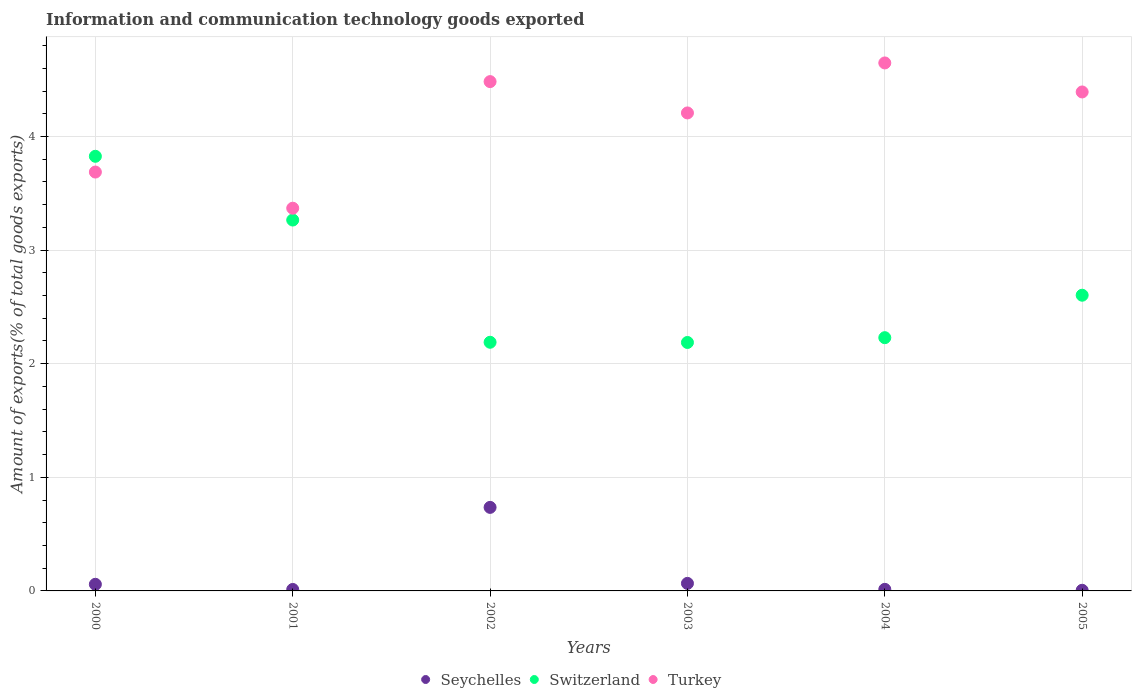How many different coloured dotlines are there?
Make the answer very short. 3. Is the number of dotlines equal to the number of legend labels?
Provide a short and direct response. Yes. What is the amount of goods exported in Switzerland in 2004?
Give a very brief answer. 2.23. Across all years, what is the maximum amount of goods exported in Seychelles?
Provide a succinct answer. 0.74. Across all years, what is the minimum amount of goods exported in Seychelles?
Provide a succinct answer. 0.01. What is the total amount of goods exported in Switzerland in the graph?
Provide a short and direct response. 16.3. What is the difference between the amount of goods exported in Switzerland in 2002 and that in 2005?
Provide a short and direct response. -0.41. What is the difference between the amount of goods exported in Seychelles in 2003 and the amount of goods exported in Turkey in 2000?
Keep it short and to the point. -3.62. What is the average amount of goods exported in Switzerland per year?
Offer a very short reply. 2.72. In the year 2001, what is the difference between the amount of goods exported in Switzerland and amount of goods exported in Turkey?
Ensure brevity in your answer.  -0.1. In how many years, is the amount of goods exported in Switzerland greater than 4.2 %?
Your answer should be very brief. 0. What is the ratio of the amount of goods exported in Switzerland in 2001 to that in 2005?
Provide a succinct answer. 1.25. What is the difference between the highest and the second highest amount of goods exported in Seychelles?
Provide a succinct answer. 0.67. What is the difference between the highest and the lowest amount of goods exported in Seychelles?
Ensure brevity in your answer.  0.73. Is the sum of the amount of goods exported in Switzerland in 2000 and 2004 greater than the maximum amount of goods exported in Seychelles across all years?
Provide a short and direct response. Yes. Is it the case that in every year, the sum of the amount of goods exported in Turkey and amount of goods exported in Switzerland  is greater than the amount of goods exported in Seychelles?
Offer a very short reply. Yes. Is the amount of goods exported in Seychelles strictly less than the amount of goods exported in Switzerland over the years?
Give a very brief answer. Yes. How many dotlines are there?
Your answer should be compact. 3. How many years are there in the graph?
Offer a terse response. 6. Does the graph contain grids?
Provide a short and direct response. Yes. How many legend labels are there?
Your response must be concise. 3. How are the legend labels stacked?
Provide a short and direct response. Horizontal. What is the title of the graph?
Give a very brief answer. Information and communication technology goods exported. Does "Guatemala" appear as one of the legend labels in the graph?
Your answer should be compact. No. What is the label or title of the X-axis?
Provide a short and direct response. Years. What is the label or title of the Y-axis?
Offer a terse response. Amount of exports(% of total goods exports). What is the Amount of exports(% of total goods exports) in Seychelles in 2000?
Provide a short and direct response. 0.06. What is the Amount of exports(% of total goods exports) of Switzerland in 2000?
Give a very brief answer. 3.83. What is the Amount of exports(% of total goods exports) in Turkey in 2000?
Give a very brief answer. 3.69. What is the Amount of exports(% of total goods exports) in Seychelles in 2001?
Offer a very short reply. 0.01. What is the Amount of exports(% of total goods exports) of Switzerland in 2001?
Your answer should be very brief. 3.26. What is the Amount of exports(% of total goods exports) in Turkey in 2001?
Offer a very short reply. 3.37. What is the Amount of exports(% of total goods exports) of Seychelles in 2002?
Your answer should be very brief. 0.74. What is the Amount of exports(% of total goods exports) of Switzerland in 2002?
Give a very brief answer. 2.19. What is the Amount of exports(% of total goods exports) in Turkey in 2002?
Make the answer very short. 4.48. What is the Amount of exports(% of total goods exports) of Seychelles in 2003?
Offer a terse response. 0.07. What is the Amount of exports(% of total goods exports) in Switzerland in 2003?
Ensure brevity in your answer.  2.19. What is the Amount of exports(% of total goods exports) of Turkey in 2003?
Give a very brief answer. 4.21. What is the Amount of exports(% of total goods exports) in Seychelles in 2004?
Offer a very short reply. 0.01. What is the Amount of exports(% of total goods exports) in Switzerland in 2004?
Your response must be concise. 2.23. What is the Amount of exports(% of total goods exports) of Turkey in 2004?
Your response must be concise. 4.65. What is the Amount of exports(% of total goods exports) in Seychelles in 2005?
Make the answer very short. 0.01. What is the Amount of exports(% of total goods exports) in Switzerland in 2005?
Provide a short and direct response. 2.6. What is the Amount of exports(% of total goods exports) in Turkey in 2005?
Provide a short and direct response. 4.39. Across all years, what is the maximum Amount of exports(% of total goods exports) of Seychelles?
Make the answer very short. 0.74. Across all years, what is the maximum Amount of exports(% of total goods exports) of Switzerland?
Provide a short and direct response. 3.83. Across all years, what is the maximum Amount of exports(% of total goods exports) in Turkey?
Your answer should be very brief. 4.65. Across all years, what is the minimum Amount of exports(% of total goods exports) of Seychelles?
Your response must be concise. 0.01. Across all years, what is the minimum Amount of exports(% of total goods exports) in Switzerland?
Ensure brevity in your answer.  2.19. Across all years, what is the minimum Amount of exports(% of total goods exports) of Turkey?
Keep it short and to the point. 3.37. What is the total Amount of exports(% of total goods exports) of Seychelles in the graph?
Provide a succinct answer. 0.89. What is the total Amount of exports(% of total goods exports) in Switzerland in the graph?
Your answer should be compact. 16.3. What is the total Amount of exports(% of total goods exports) of Turkey in the graph?
Your answer should be very brief. 24.78. What is the difference between the Amount of exports(% of total goods exports) of Seychelles in 2000 and that in 2001?
Provide a succinct answer. 0.05. What is the difference between the Amount of exports(% of total goods exports) in Switzerland in 2000 and that in 2001?
Ensure brevity in your answer.  0.56. What is the difference between the Amount of exports(% of total goods exports) of Turkey in 2000 and that in 2001?
Provide a succinct answer. 0.32. What is the difference between the Amount of exports(% of total goods exports) in Seychelles in 2000 and that in 2002?
Make the answer very short. -0.68. What is the difference between the Amount of exports(% of total goods exports) of Switzerland in 2000 and that in 2002?
Your answer should be compact. 1.64. What is the difference between the Amount of exports(% of total goods exports) in Turkey in 2000 and that in 2002?
Your answer should be compact. -0.8. What is the difference between the Amount of exports(% of total goods exports) of Seychelles in 2000 and that in 2003?
Provide a short and direct response. -0.01. What is the difference between the Amount of exports(% of total goods exports) of Switzerland in 2000 and that in 2003?
Ensure brevity in your answer.  1.64. What is the difference between the Amount of exports(% of total goods exports) of Turkey in 2000 and that in 2003?
Provide a succinct answer. -0.52. What is the difference between the Amount of exports(% of total goods exports) in Seychelles in 2000 and that in 2004?
Provide a succinct answer. 0.04. What is the difference between the Amount of exports(% of total goods exports) of Switzerland in 2000 and that in 2004?
Your answer should be compact. 1.6. What is the difference between the Amount of exports(% of total goods exports) of Turkey in 2000 and that in 2004?
Offer a terse response. -0.96. What is the difference between the Amount of exports(% of total goods exports) of Seychelles in 2000 and that in 2005?
Your answer should be compact. 0.05. What is the difference between the Amount of exports(% of total goods exports) in Switzerland in 2000 and that in 2005?
Your response must be concise. 1.22. What is the difference between the Amount of exports(% of total goods exports) of Turkey in 2000 and that in 2005?
Your answer should be compact. -0.7. What is the difference between the Amount of exports(% of total goods exports) in Seychelles in 2001 and that in 2002?
Give a very brief answer. -0.72. What is the difference between the Amount of exports(% of total goods exports) in Switzerland in 2001 and that in 2002?
Your response must be concise. 1.08. What is the difference between the Amount of exports(% of total goods exports) in Turkey in 2001 and that in 2002?
Offer a terse response. -1.11. What is the difference between the Amount of exports(% of total goods exports) of Seychelles in 2001 and that in 2003?
Your answer should be very brief. -0.05. What is the difference between the Amount of exports(% of total goods exports) in Switzerland in 2001 and that in 2003?
Your answer should be very brief. 1.08. What is the difference between the Amount of exports(% of total goods exports) of Turkey in 2001 and that in 2003?
Your response must be concise. -0.84. What is the difference between the Amount of exports(% of total goods exports) in Seychelles in 2001 and that in 2004?
Provide a short and direct response. -0. What is the difference between the Amount of exports(% of total goods exports) in Switzerland in 2001 and that in 2004?
Give a very brief answer. 1.04. What is the difference between the Amount of exports(% of total goods exports) in Turkey in 2001 and that in 2004?
Give a very brief answer. -1.28. What is the difference between the Amount of exports(% of total goods exports) of Seychelles in 2001 and that in 2005?
Provide a succinct answer. 0.01. What is the difference between the Amount of exports(% of total goods exports) of Switzerland in 2001 and that in 2005?
Your answer should be very brief. 0.66. What is the difference between the Amount of exports(% of total goods exports) in Turkey in 2001 and that in 2005?
Keep it short and to the point. -1.02. What is the difference between the Amount of exports(% of total goods exports) of Seychelles in 2002 and that in 2003?
Make the answer very short. 0.67. What is the difference between the Amount of exports(% of total goods exports) in Switzerland in 2002 and that in 2003?
Ensure brevity in your answer.  0. What is the difference between the Amount of exports(% of total goods exports) of Turkey in 2002 and that in 2003?
Your answer should be compact. 0.28. What is the difference between the Amount of exports(% of total goods exports) in Seychelles in 2002 and that in 2004?
Ensure brevity in your answer.  0.72. What is the difference between the Amount of exports(% of total goods exports) in Switzerland in 2002 and that in 2004?
Your answer should be compact. -0.04. What is the difference between the Amount of exports(% of total goods exports) in Turkey in 2002 and that in 2004?
Ensure brevity in your answer.  -0.16. What is the difference between the Amount of exports(% of total goods exports) in Seychelles in 2002 and that in 2005?
Offer a very short reply. 0.73. What is the difference between the Amount of exports(% of total goods exports) in Switzerland in 2002 and that in 2005?
Your answer should be compact. -0.41. What is the difference between the Amount of exports(% of total goods exports) in Turkey in 2002 and that in 2005?
Give a very brief answer. 0.09. What is the difference between the Amount of exports(% of total goods exports) in Seychelles in 2003 and that in 2004?
Make the answer very short. 0.05. What is the difference between the Amount of exports(% of total goods exports) of Switzerland in 2003 and that in 2004?
Your response must be concise. -0.04. What is the difference between the Amount of exports(% of total goods exports) of Turkey in 2003 and that in 2004?
Provide a short and direct response. -0.44. What is the difference between the Amount of exports(% of total goods exports) of Seychelles in 2003 and that in 2005?
Keep it short and to the point. 0.06. What is the difference between the Amount of exports(% of total goods exports) of Switzerland in 2003 and that in 2005?
Your response must be concise. -0.42. What is the difference between the Amount of exports(% of total goods exports) in Turkey in 2003 and that in 2005?
Provide a short and direct response. -0.18. What is the difference between the Amount of exports(% of total goods exports) in Seychelles in 2004 and that in 2005?
Keep it short and to the point. 0.01. What is the difference between the Amount of exports(% of total goods exports) in Switzerland in 2004 and that in 2005?
Your response must be concise. -0.37. What is the difference between the Amount of exports(% of total goods exports) in Turkey in 2004 and that in 2005?
Ensure brevity in your answer.  0.26. What is the difference between the Amount of exports(% of total goods exports) in Seychelles in 2000 and the Amount of exports(% of total goods exports) in Switzerland in 2001?
Ensure brevity in your answer.  -3.21. What is the difference between the Amount of exports(% of total goods exports) in Seychelles in 2000 and the Amount of exports(% of total goods exports) in Turkey in 2001?
Your answer should be very brief. -3.31. What is the difference between the Amount of exports(% of total goods exports) of Switzerland in 2000 and the Amount of exports(% of total goods exports) of Turkey in 2001?
Offer a very short reply. 0.46. What is the difference between the Amount of exports(% of total goods exports) of Seychelles in 2000 and the Amount of exports(% of total goods exports) of Switzerland in 2002?
Offer a very short reply. -2.13. What is the difference between the Amount of exports(% of total goods exports) in Seychelles in 2000 and the Amount of exports(% of total goods exports) in Turkey in 2002?
Keep it short and to the point. -4.42. What is the difference between the Amount of exports(% of total goods exports) of Switzerland in 2000 and the Amount of exports(% of total goods exports) of Turkey in 2002?
Give a very brief answer. -0.66. What is the difference between the Amount of exports(% of total goods exports) in Seychelles in 2000 and the Amount of exports(% of total goods exports) in Switzerland in 2003?
Your answer should be compact. -2.13. What is the difference between the Amount of exports(% of total goods exports) in Seychelles in 2000 and the Amount of exports(% of total goods exports) in Turkey in 2003?
Your answer should be compact. -4.15. What is the difference between the Amount of exports(% of total goods exports) in Switzerland in 2000 and the Amount of exports(% of total goods exports) in Turkey in 2003?
Your answer should be very brief. -0.38. What is the difference between the Amount of exports(% of total goods exports) in Seychelles in 2000 and the Amount of exports(% of total goods exports) in Switzerland in 2004?
Give a very brief answer. -2.17. What is the difference between the Amount of exports(% of total goods exports) in Seychelles in 2000 and the Amount of exports(% of total goods exports) in Turkey in 2004?
Your response must be concise. -4.59. What is the difference between the Amount of exports(% of total goods exports) in Switzerland in 2000 and the Amount of exports(% of total goods exports) in Turkey in 2004?
Keep it short and to the point. -0.82. What is the difference between the Amount of exports(% of total goods exports) in Seychelles in 2000 and the Amount of exports(% of total goods exports) in Switzerland in 2005?
Provide a succinct answer. -2.54. What is the difference between the Amount of exports(% of total goods exports) of Seychelles in 2000 and the Amount of exports(% of total goods exports) of Turkey in 2005?
Keep it short and to the point. -4.33. What is the difference between the Amount of exports(% of total goods exports) in Switzerland in 2000 and the Amount of exports(% of total goods exports) in Turkey in 2005?
Give a very brief answer. -0.57. What is the difference between the Amount of exports(% of total goods exports) in Seychelles in 2001 and the Amount of exports(% of total goods exports) in Switzerland in 2002?
Provide a short and direct response. -2.18. What is the difference between the Amount of exports(% of total goods exports) in Seychelles in 2001 and the Amount of exports(% of total goods exports) in Turkey in 2002?
Your answer should be very brief. -4.47. What is the difference between the Amount of exports(% of total goods exports) in Switzerland in 2001 and the Amount of exports(% of total goods exports) in Turkey in 2002?
Provide a succinct answer. -1.22. What is the difference between the Amount of exports(% of total goods exports) in Seychelles in 2001 and the Amount of exports(% of total goods exports) in Switzerland in 2003?
Your answer should be compact. -2.17. What is the difference between the Amount of exports(% of total goods exports) in Seychelles in 2001 and the Amount of exports(% of total goods exports) in Turkey in 2003?
Provide a succinct answer. -4.19. What is the difference between the Amount of exports(% of total goods exports) in Switzerland in 2001 and the Amount of exports(% of total goods exports) in Turkey in 2003?
Keep it short and to the point. -0.94. What is the difference between the Amount of exports(% of total goods exports) in Seychelles in 2001 and the Amount of exports(% of total goods exports) in Switzerland in 2004?
Provide a short and direct response. -2.22. What is the difference between the Amount of exports(% of total goods exports) in Seychelles in 2001 and the Amount of exports(% of total goods exports) in Turkey in 2004?
Ensure brevity in your answer.  -4.63. What is the difference between the Amount of exports(% of total goods exports) in Switzerland in 2001 and the Amount of exports(% of total goods exports) in Turkey in 2004?
Your answer should be very brief. -1.38. What is the difference between the Amount of exports(% of total goods exports) of Seychelles in 2001 and the Amount of exports(% of total goods exports) of Switzerland in 2005?
Give a very brief answer. -2.59. What is the difference between the Amount of exports(% of total goods exports) in Seychelles in 2001 and the Amount of exports(% of total goods exports) in Turkey in 2005?
Provide a succinct answer. -4.38. What is the difference between the Amount of exports(% of total goods exports) in Switzerland in 2001 and the Amount of exports(% of total goods exports) in Turkey in 2005?
Provide a short and direct response. -1.13. What is the difference between the Amount of exports(% of total goods exports) of Seychelles in 2002 and the Amount of exports(% of total goods exports) of Switzerland in 2003?
Ensure brevity in your answer.  -1.45. What is the difference between the Amount of exports(% of total goods exports) of Seychelles in 2002 and the Amount of exports(% of total goods exports) of Turkey in 2003?
Make the answer very short. -3.47. What is the difference between the Amount of exports(% of total goods exports) in Switzerland in 2002 and the Amount of exports(% of total goods exports) in Turkey in 2003?
Keep it short and to the point. -2.02. What is the difference between the Amount of exports(% of total goods exports) in Seychelles in 2002 and the Amount of exports(% of total goods exports) in Switzerland in 2004?
Provide a succinct answer. -1.49. What is the difference between the Amount of exports(% of total goods exports) in Seychelles in 2002 and the Amount of exports(% of total goods exports) in Turkey in 2004?
Offer a very short reply. -3.91. What is the difference between the Amount of exports(% of total goods exports) of Switzerland in 2002 and the Amount of exports(% of total goods exports) of Turkey in 2004?
Give a very brief answer. -2.46. What is the difference between the Amount of exports(% of total goods exports) of Seychelles in 2002 and the Amount of exports(% of total goods exports) of Switzerland in 2005?
Make the answer very short. -1.87. What is the difference between the Amount of exports(% of total goods exports) in Seychelles in 2002 and the Amount of exports(% of total goods exports) in Turkey in 2005?
Keep it short and to the point. -3.66. What is the difference between the Amount of exports(% of total goods exports) of Switzerland in 2002 and the Amount of exports(% of total goods exports) of Turkey in 2005?
Your answer should be compact. -2.2. What is the difference between the Amount of exports(% of total goods exports) in Seychelles in 2003 and the Amount of exports(% of total goods exports) in Switzerland in 2004?
Your answer should be compact. -2.16. What is the difference between the Amount of exports(% of total goods exports) of Seychelles in 2003 and the Amount of exports(% of total goods exports) of Turkey in 2004?
Provide a succinct answer. -4.58. What is the difference between the Amount of exports(% of total goods exports) of Switzerland in 2003 and the Amount of exports(% of total goods exports) of Turkey in 2004?
Your response must be concise. -2.46. What is the difference between the Amount of exports(% of total goods exports) in Seychelles in 2003 and the Amount of exports(% of total goods exports) in Switzerland in 2005?
Provide a short and direct response. -2.54. What is the difference between the Amount of exports(% of total goods exports) in Seychelles in 2003 and the Amount of exports(% of total goods exports) in Turkey in 2005?
Offer a very short reply. -4.33. What is the difference between the Amount of exports(% of total goods exports) in Switzerland in 2003 and the Amount of exports(% of total goods exports) in Turkey in 2005?
Your answer should be very brief. -2.21. What is the difference between the Amount of exports(% of total goods exports) in Seychelles in 2004 and the Amount of exports(% of total goods exports) in Switzerland in 2005?
Offer a very short reply. -2.59. What is the difference between the Amount of exports(% of total goods exports) in Seychelles in 2004 and the Amount of exports(% of total goods exports) in Turkey in 2005?
Provide a succinct answer. -4.38. What is the difference between the Amount of exports(% of total goods exports) in Switzerland in 2004 and the Amount of exports(% of total goods exports) in Turkey in 2005?
Provide a short and direct response. -2.16. What is the average Amount of exports(% of total goods exports) in Seychelles per year?
Offer a terse response. 0.15. What is the average Amount of exports(% of total goods exports) of Switzerland per year?
Keep it short and to the point. 2.72. What is the average Amount of exports(% of total goods exports) of Turkey per year?
Your response must be concise. 4.13. In the year 2000, what is the difference between the Amount of exports(% of total goods exports) in Seychelles and Amount of exports(% of total goods exports) in Switzerland?
Provide a short and direct response. -3.77. In the year 2000, what is the difference between the Amount of exports(% of total goods exports) in Seychelles and Amount of exports(% of total goods exports) in Turkey?
Your answer should be very brief. -3.63. In the year 2000, what is the difference between the Amount of exports(% of total goods exports) of Switzerland and Amount of exports(% of total goods exports) of Turkey?
Your answer should be compact. 0.14. In the year 2001, what is the difference between the Amount of exports(% of total goods exports) of Seychelles and Amount of exports(% of total goods exports) of Switzerland?
Offer a terse response. -3.25. In the year 2001, what is the difference between the Amount of exports(% of total goods exports) of Seychelles and Amount of exports(% of total goods exports) of Turkey?
Your answer should be very brief. -3.36. In the year 2001, what is the difference between the Amount of exports(% of total goods exports) of Switzerland and Amount of exports(% of total goods exports) of Turkey?
Make the answer very short. -0.1. In the year 2002, what is the difference between the Amount of exports(% of total goods exports) of Seychelles and Amount of exports(% of total goods exports) of Switzerland?
Give a very brief answer. -1.45. In the year 2002, what is the difference between the Amount of exports(% of total goods exports) of Seychelles and Amount of exports(% of total goods exports) of Turkey?
Your response must be concise. -3.75. In the year 2002, what is the difference between the Amount of exports(% of total goods exports) in Switzerland and Amount of exports(% of total goods exports) in Turkey?
Offer a very short reply. -2.29. In the year 2003, what is the difference between the Amount of exports(% of total goods exports) in Seychelles and Amount of exports(% of total goods exports) in Switzerland?
Your response must be concise. -2.12. In the year 2003, what is the difference between the Amount of exports(% of total goods exports) in Seychelles and Amount of exports(% of total goods exports) in Turkey?
Provide a short and direct response. -4.14. In the year 2003, what is the difference between the Amount of exports(% of total goods exports) of Switzerland and Amount of exports(% of total goods exports) of Turkey?
Your answer should be very brief. -2.02. In the year 2004, what is the difference between the Amount of exports(% of total goods exports) in Seychelles and Amount of exports(% of total goods exports) in Switzerland?
Your response must be concise. -2.22. In the year 2004, what is the difference between the Amount of exports(% of total goods exports) of Seychelles and Amount of exports(% of total goods exports) of Turkey?
Offer a terse response. -4.63. In the year 2004, what is the difference between the Amount of exports(% of total goods exports) of Switzerland and Amount of exports(% of total goods exports) of Turkey?
Your response must be concise. -2.42. In the year 2005, what is the difference between the Amount of exports(% of total goods exports) of Seychelles and Amount of exports(% of total goods exports) of Switzerland?
Provide a succinct answer. -2.6. In the year 2005, what is the difference between the Amount of exports(% of total goods exports) in Seychelles and Amount of exports(% of total goods exports) in Turkey?
Offer a very short reply. -4.39. In the year 2005, what is the difference between the Amount of exports(% of total goods exports) of Switzerland and Amount of exports(% of total goods exports) of Turkey?
Your answer should be very brief. -1.79. What is the ratio of the Amount of exports(% of total goods exports) in Seychelles in 2000 to that in 2001?
Your answer should be very brief. 4.5. What is the ratio of the Amount of exports(% of total goods exports) of Switzerland in 2000 to that in 2001?
Your response must be concise. 1.17. What is the ratio of the Amount of exports(% of total goods exports) in Turkey in 2000 to that in 2001?
Make the answer very short. 1.09. What is the ratio of the Amount of exports(% of total goods exports) of Seychelles in 2000 to that in 2002?
Provide a short and direct response. 0.08. What is the ratio of the Amount of exports(% of total goods exports) of Switzerland in 2000 to that in 2002?
Offer a very short reply. 1.75. What is the ratio of the Amount of exports(% of total goods exports) of Turkey in 2000 to that in 2002?
Your answer should be very brief. 0.82. What is the ratio of the Amount of exports(% of total goods exports) in Seychelles in 2000 to that in 2003?
Provide a succinct answer. 0.88. What is the ratio of the Amount of exports(% of total goods exports) of Switzerland in 2000 to that in 2003?
Provide a succinct answer. 1.75. What is the ratio of the Amount of exports(% of total goods exports) of Turkey in 2000 to that in 2003?
Your answer should be compact. 0.88. What is the ratio of the Amount of exports(% of total goods exports) in Seychelles in 2000 to that in 2004?
Offer a very short reply. 4.21. What is the ratio of the Amount of exports(% of total goods exports) of Switzerland in 2000 to that in 2004?
Keep it short and to the point. 1.72. What is the ratio of the Amount of exports(% of total goods exports) of Turkey in 2000 to that in 2004?
Provide a short and direct response. 0.79. What is the ratio of the Amount of exports(% of total goods exports) in Seychelles in 2000 to that in 2005?
Provide a succinct answer. 10.38. What is the ratio of the Amount of exports(% of total goods exports) in Switzerland in 2000 to that in 2005?
Ensure brevity in your answer.  1.47. What is the ratio of the Amount of exports(% of total goods exports) in Turkey in 2000 to that in 2005?
Offer a terse response. 0.84. What is the ratio of the Amount of exports(% of total goods exports) in Seychelles in 2001 to that in 2002?
Offer a terse response. 0.02. What is the ratio of the Amount of exports(% of total goods exports) in Switzerland in 2001 to that in 2002?
Provide a short and direct response. 1.49. What is the ratio of the Amount of exports(% of total goods exports) of Turkey in 2001 to that in 2002?
Your answer should be very brief. 0.75. What is the ratio of the Amount of exports(% of total goods exports) of Seychelles in 2001 to that in 2003?
Ensure brevity in your answer.  0.19. What is the ratio of the Amount of exports(% of total goods exports) in Switzerland in 2001 to that in 2003?
Ensure brevity in your answer.  1.49. What is the ratio of the Amount of exports(% of total goods exports) of Turkey in 2001 to that in 2003?
Your response must be concise. 0.8. What is the ratio of the Amount of exports(% of total goods exports) in Seychelles in 2001 to that in 2004?
Provide a succinct answer. 0.94. What is the ratio of the Amount of exports(% of total goods exports) in Switzerland in 2001 to that in 2004?
Ensure brevity in your answer.  1.46. What is the ratio of the Amount of exports(% of total goods exports) of Turkey in 2001 to that in 2004?
Offer a terse response. 0.72. What is the ratio of the Amount of exports(% of total goods exports) of Seychelles in 2001 to that in 2005?
Provide a succinct answer. 2.31. What is the ratio of the Amount of exports(% of total goods exports) of Switzerland in 2001 to that in 2005?
Keep it short and to the point. 1.25. What is the ratio of the Amount of exports(% of total goods exports) of Turkey in 2001 to that in 2005?
Provide a succinct answer. 0.77. What is the ratio of the Amount of exports(% of total goods exports) in Seychelles in 2002 to that in 2003?
Your response must be concise. 11.08. What is the ratio of the Amount of exports(% of total goods exports) in Turkey in 2002 to that in 2003?
Ensure brevity in your answer.  1.07. What is the ratio of the Amount of exports(% of total goods exports) of Seychelles in 2002 to that in 2004?
Provide a short and direct response. 53.2. What is the ratio of the Amount of exports(% of total goods exports) in Switzerland in 2002 to that in 2004?
Offer a terse response. 0.98. What is the ratio of the Amount of exports(% of total goods exports) of Turkey in 2002 to that in 2004?
Keep it short and to the point. 0.96. What is the ratio of the Amount of exports(% of total goods exports) in Seychelles in 2002 to that in 2005?
Your answer should be very brief. 131.22. What is the ratio of the Amount of exports(% of total goods exports) in Switzerland in 2002 to that in 2005?
Give a very brief answer. 0.84. What is the ratio of the Amount of exports(% of total goods exports) in Turkey in 2002 to that in 2005?
Offer a very short reply. 1.02. What is the ratio of the Amount of exports(% of total goods exports) of Seychelles in 2003 to that in 2004?
Offer a terse response. 4.8. What is the ratio of the Amount of exports(% of total goods exports) in Switzerland in 2003 to that in 2004?
Your answer should be very brief. 0.98. What is the ratio of the Amount of exports(% of total goods exports) of Turkey in 2003 to that in 2004?
Provide a short and direct response. 0.91. What is the ratio of the Amount of exports(% of total goods exports) of Seychelles in 2003 to that in 2005?
Keep it short and to the point. 11.84. What is the ratio of the Amount of exports(% of total goods exports) in Switzerland in 2003 to that in 2005?
Your answer should be very brief. 0.84. What is the ratio of the Amount of exports(% of total goods exports) of Turkey in 2003 to that in 2005?
Offer a very short reply. 0.96. What is the ratio of the Amount of exports(% of total goods exports) of Seychelles in 2004 to that in 2005?
Your response must be concise. 2.47. What is the ratio of the Amount of exports(% of total goods exports) of Switzerland in 2004 to that in 2005?
Provide a short and direct response. 0.86. What is the ratio of the Amount of exports(% of total goods exports) in Turkey in 2004 to that in 2005?
Your answer should be very brief. 1.06. What is the difference between the highest and the second highest Amount of exports(% of total goods exports) of Seychelles?
Provide a succinct answer. 0.67. What is the difference between the highest and the second highest Amount of exports(% of total goods exports) of Switzerland?
Your answer should be very brief. 0.56. What is the difference between the highest and the second highest Amount of exports(% of total goods exports) of Turkey?
Ensure brevity in your answer.  0.16. What is the difference between the highest and the lowest Amount of exports(% of total goods exports) in Seychelles?
Your response must be concise. 0.73. What is the difference between the highest and the lowest Amount of exports(% of total goods exports) in Switzerland?
Provide a succinct answer. 1.64. What is the difference between the highest and the lowest Amount of exports(% of total goods exports) in Turkey?
Make the answer very short. 1.28. 